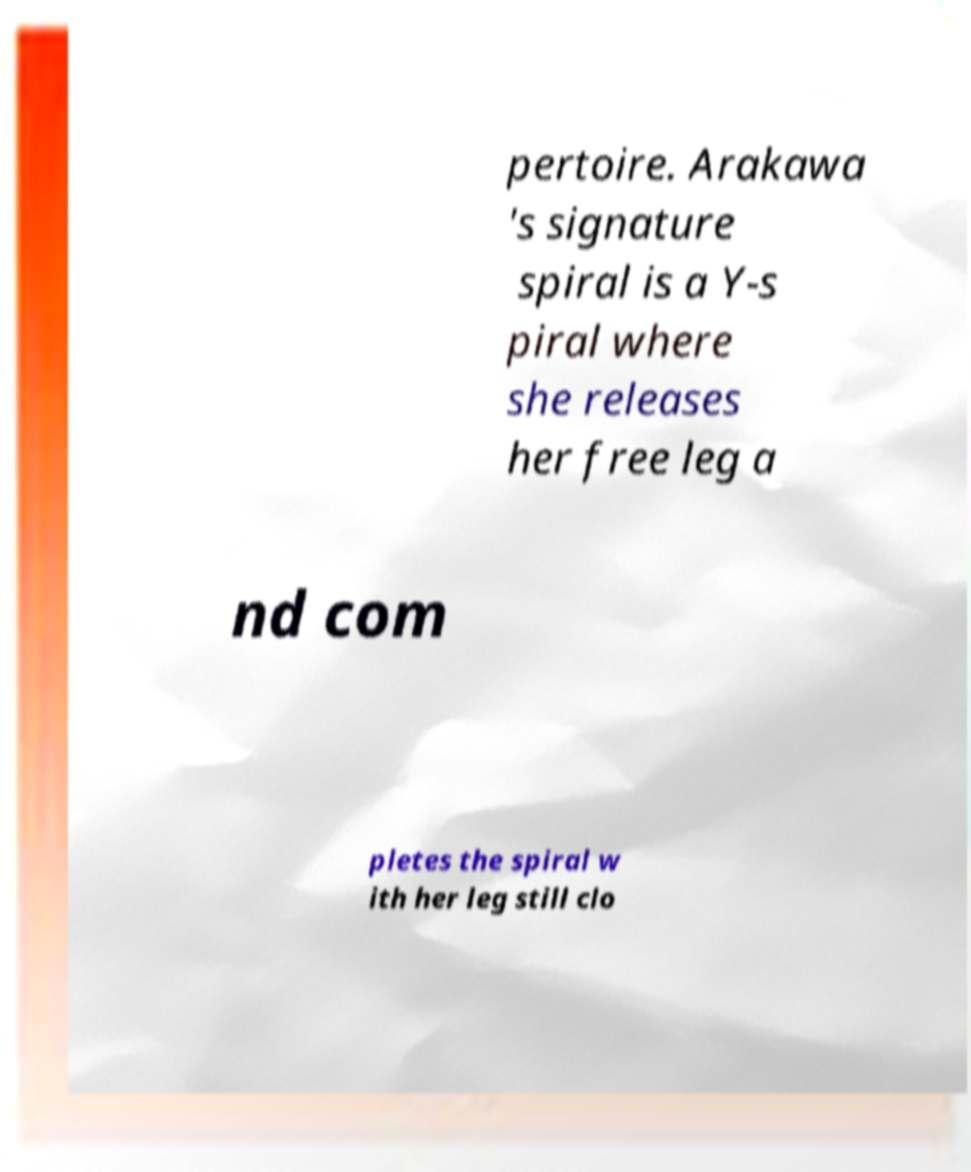What messages or text are displayed in this image? I need them in a readable, typed format. pertoire. Arakawa 's signature spiral is a Y-s piral where she releases her free leg a nd com pletes the spiral w ith her leg still clo 